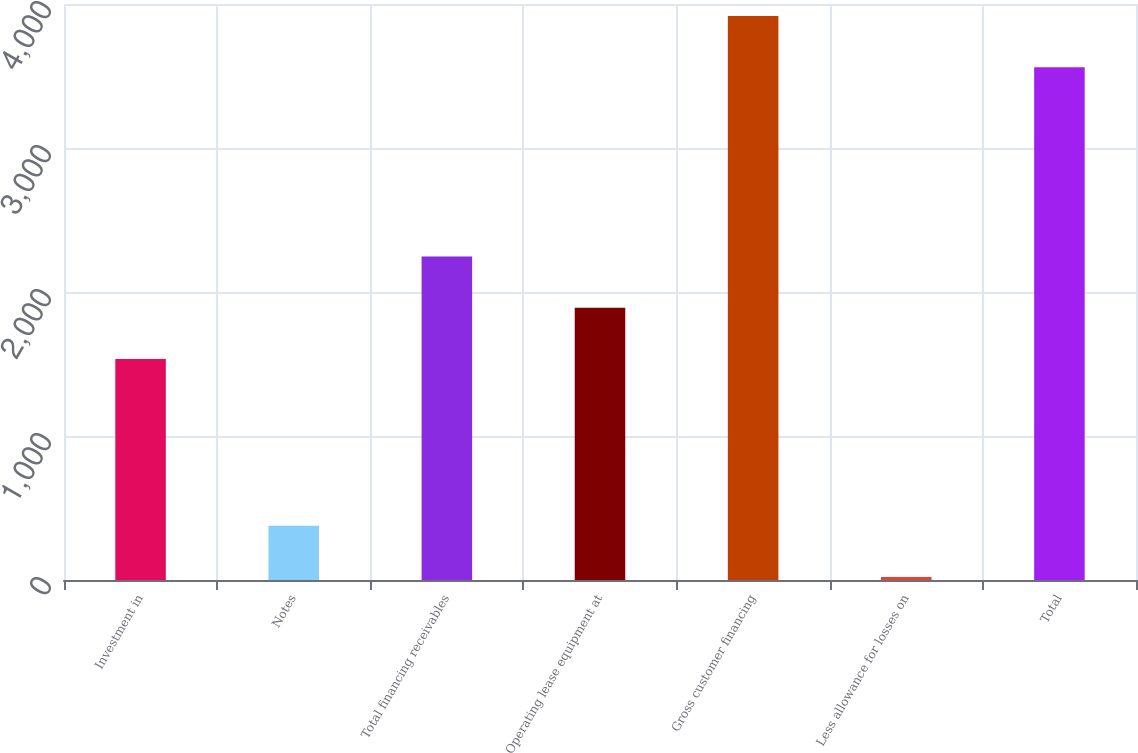<chart> <loc_0><loc_0><loc_500><loc_500><bar_chart><fcel>Investment in<fcel>Notes<fcel>Total financing receivables<fcel>Operating lease equipment at<fcel>Gross customer financing<fcel>Less allowance for losses on<fcel>Total<nl><fcel>1535<fcel>377.1<fcel>2247.2<fcel>1891.1<fcel>3917.1<fcel>21<fcel>3561<nl></chart> 